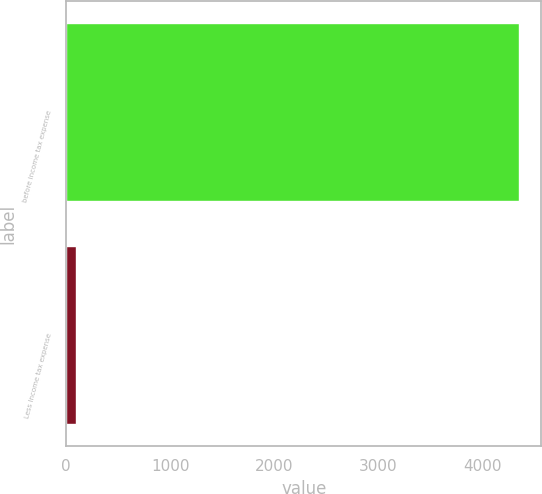Convert chart. <chart><loc_0><loc_0><loc_500><loc_500><bar_chart><fcel>before income tax expense<fcel>Less Income tax expense<nl><fcel>4350<fcel>93<nl></chart> 